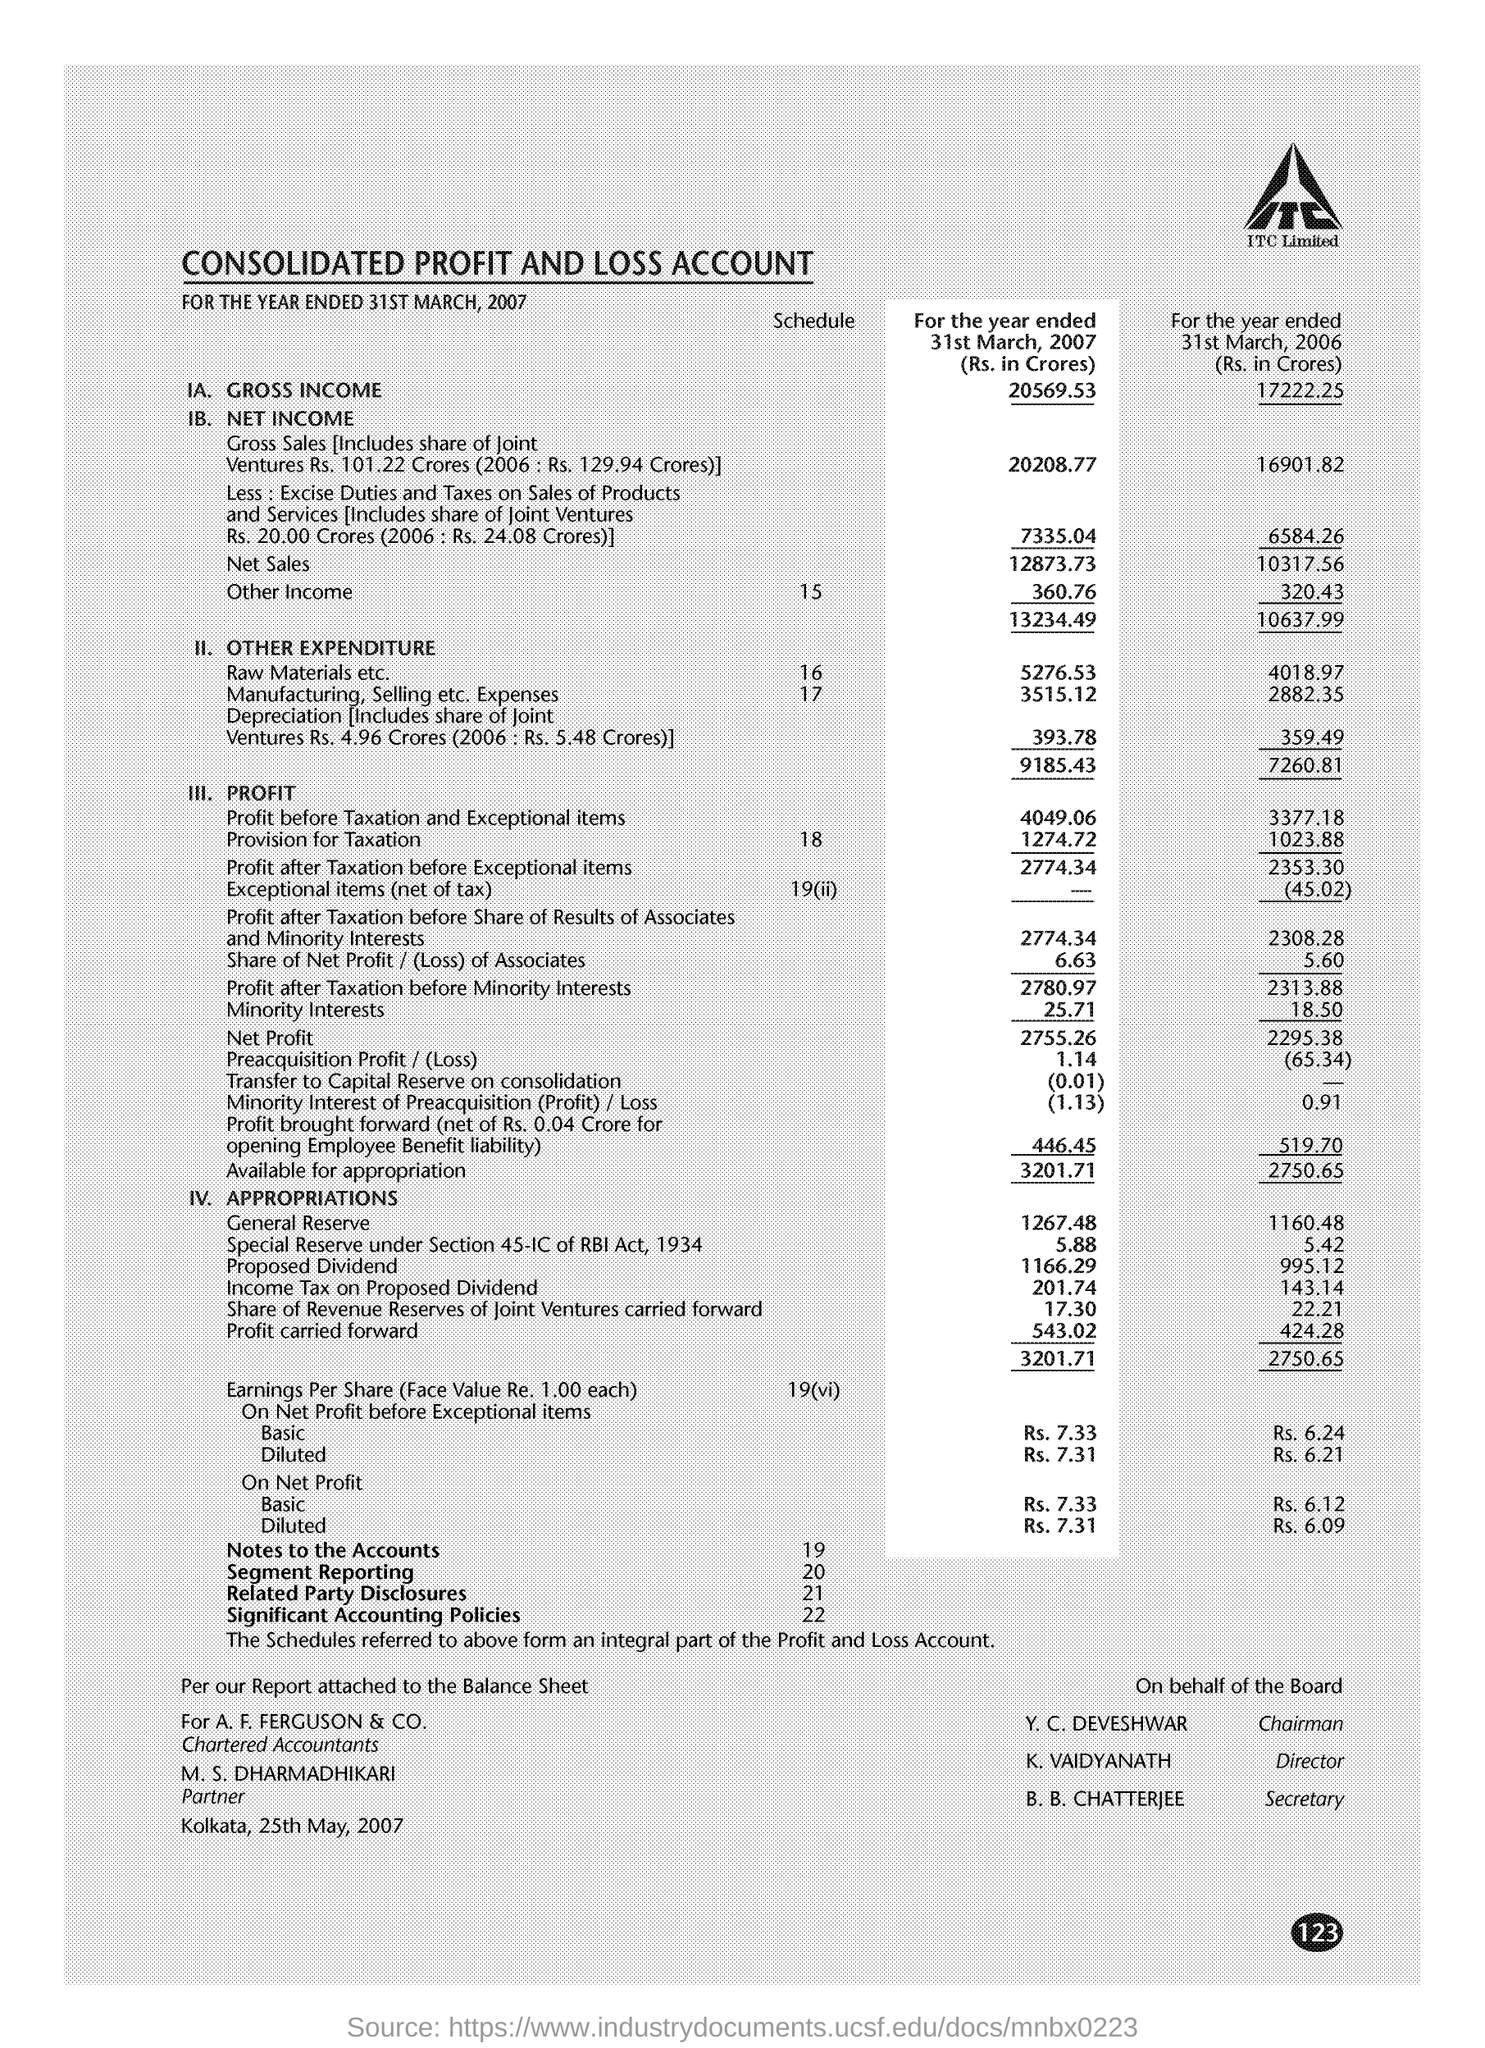Who is the chairman?
Offer a very short reply. Y.C. Deveshwar. Special reserve is created under which section of RBI act?
Offer a terse response. 45-IC. 